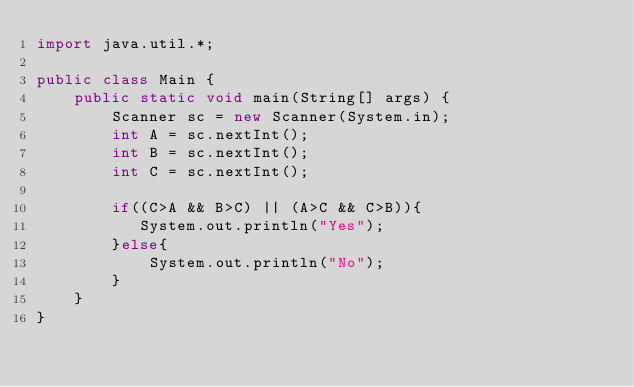<code> <loc_0><loc_0><loc_500><loc_500><_Java_>import java.util.*;

public class Main {
    public static void main(String[] args) {
        Scanner sc = new Scanner(System.in);
        int A = sc.nextInt();
        int B = sc.nextInt();
        int C = sc.nextInt();
        
        if((C>A && B>C) || (A>C && C>B)){
           System.out.println("Yes"); 
        }else{
            System.out.println("No");
        }
    }
}
</code> 